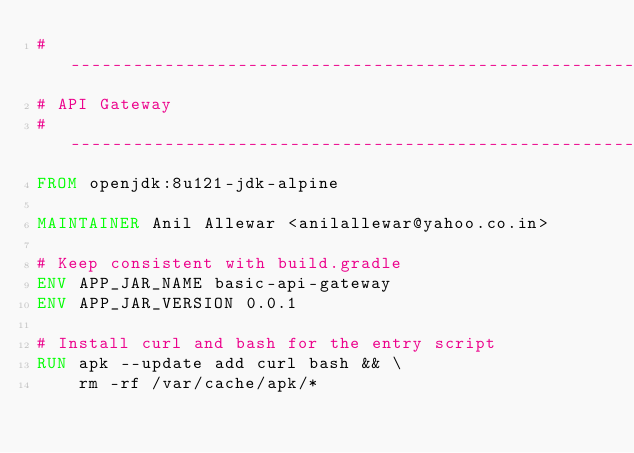Convert code to text. <code><loc_0><loc_0><loc_500><loc_500><_Dockerfile_>#-----------------------------------------------------------------------------------------------------
# API Gateway
#-----------------------------------------------------------------------------------------------------
FROM openjdk:8u121-jdk-alpine

MAINTAINER Anil Allewar <anilallewar@yahoo.co.in>

# Keep consistent with build.gradle 
ENV APP_JAR_NAME basic-api-gateway
ENV APP_JAR_VERSION 0.0.1

# Install curl and bash for the entry script
RUN apk --update add curl bash && \
	rm -rf /var/cache/apk/*
	</code> 